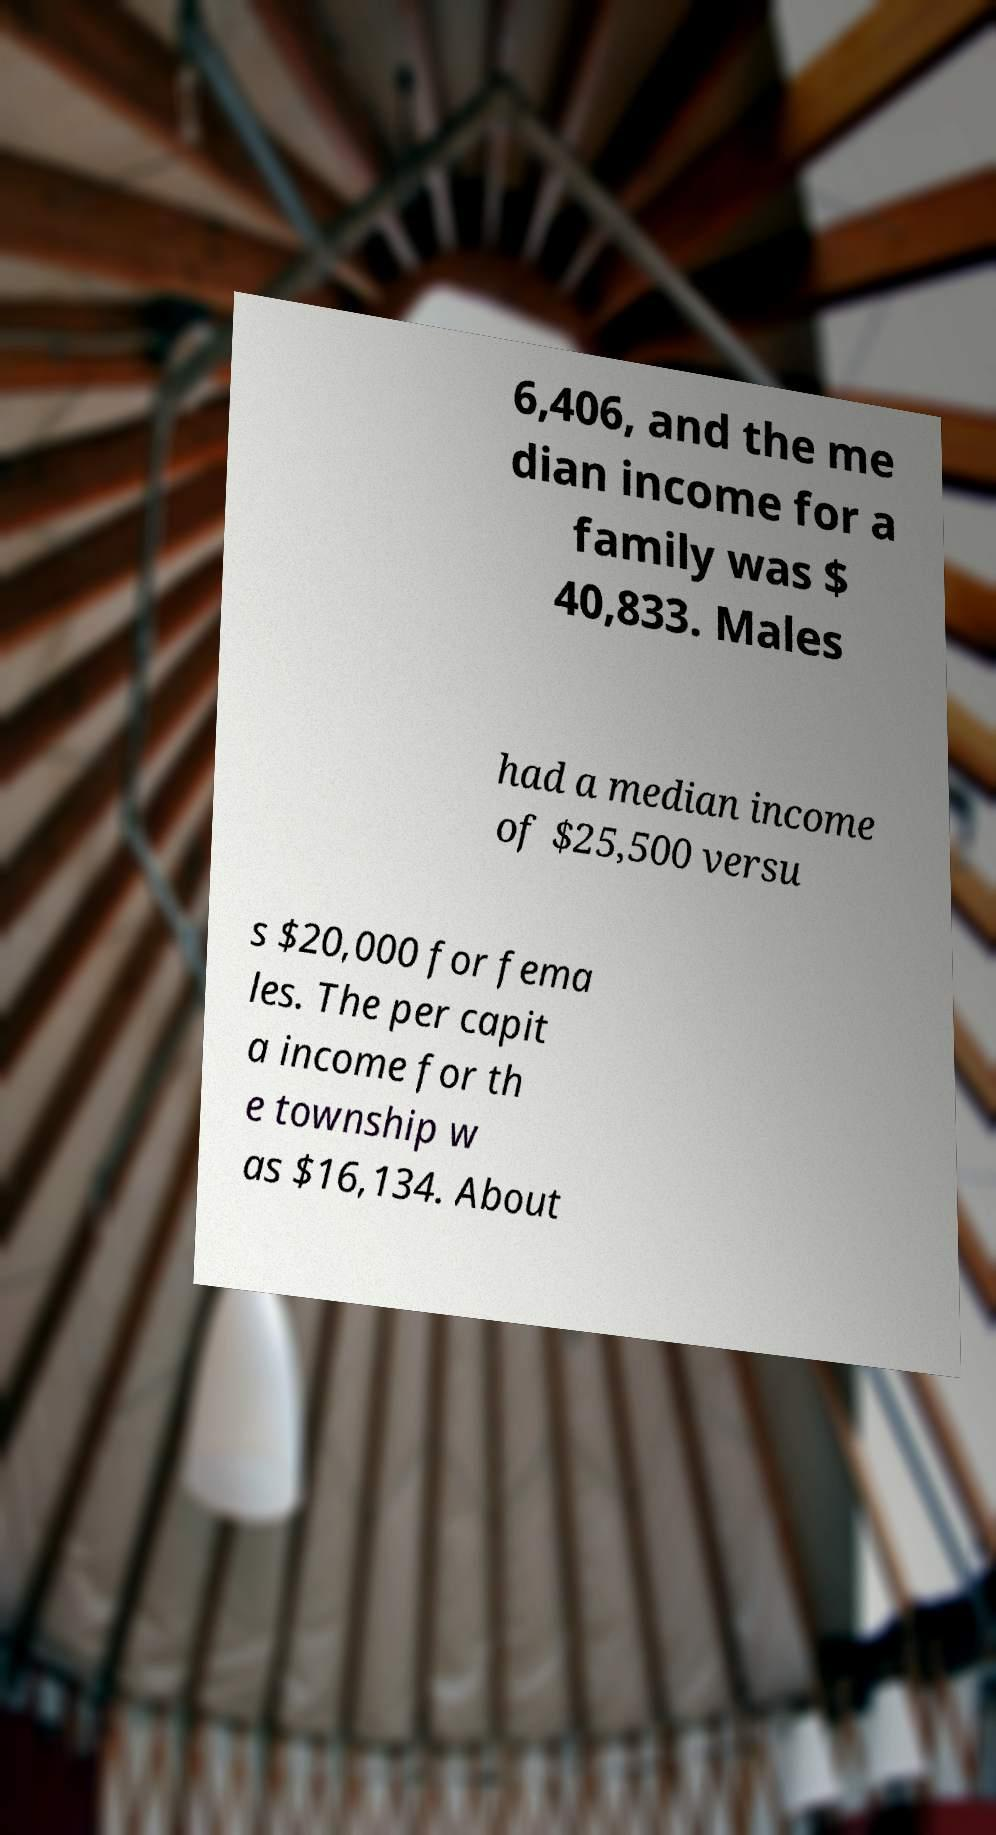Could you assist in decoding the text presented in this image and type it out clearly? 6,406, and the me dian income for a family was $ 40,833. Males had a median income of $25,500 versu s $20,000 for fema les. The per capit a income for th e township w as $16,134. About 